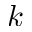Convert formula to latex. <formula><loc_0><loc_0><loc_500><loc_500>k</formula> 